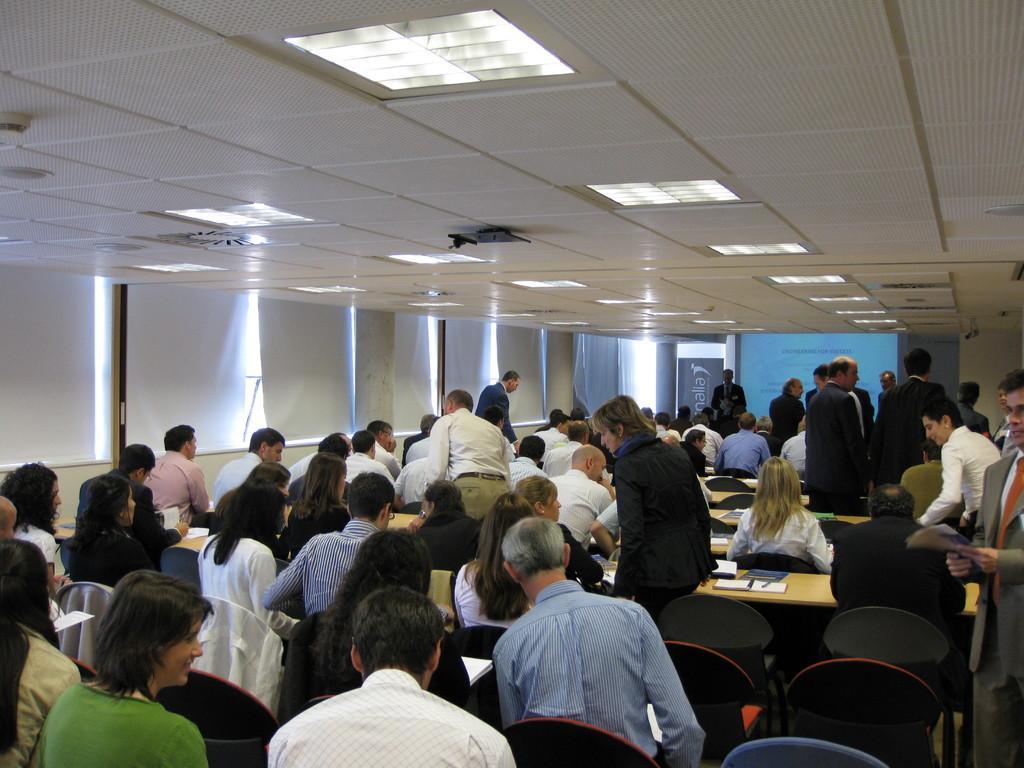Describe this image in one or two sentences. In the picture we can see an office seminar room with employees sitting in the chairs near the desks and on the desks we can see some books and pen and in the background, we can see a glass window and curtains to and we can also see a screen and to the ceiling we can see the lights. 